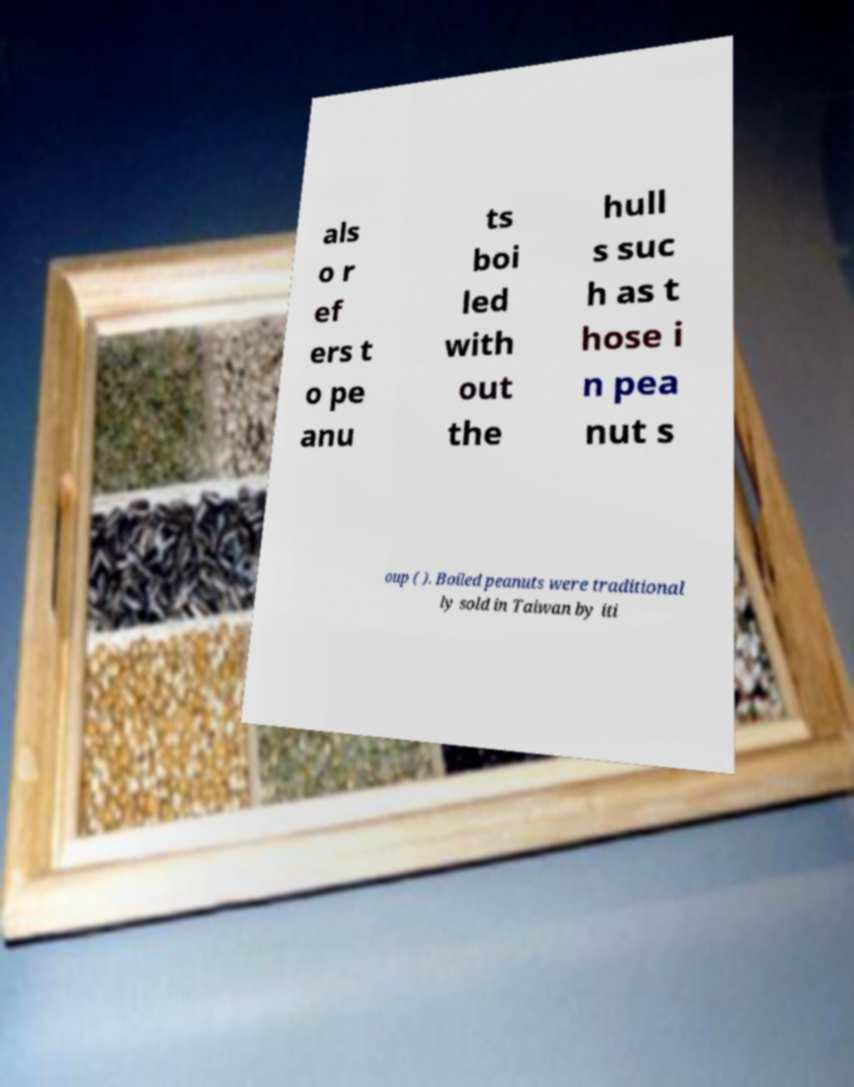For documentation purposes, I need the text within this image transcribed. Could you provide that? als o r ef ers t o pe anu ts boi led with out the hull s suc h as t hose i n pea nut s oup ( ). Boiled peanuts were traditional ly sold in Taiwan by iti 